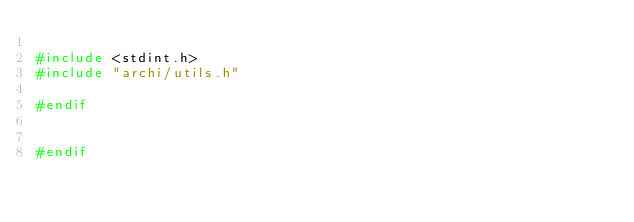Convert code to text. <code><loc_0><loc_0><loc_500><loc_500><_C_>
#include <stdint.h>
#include "archi/utils.h"

#endif


#endif
</code> 